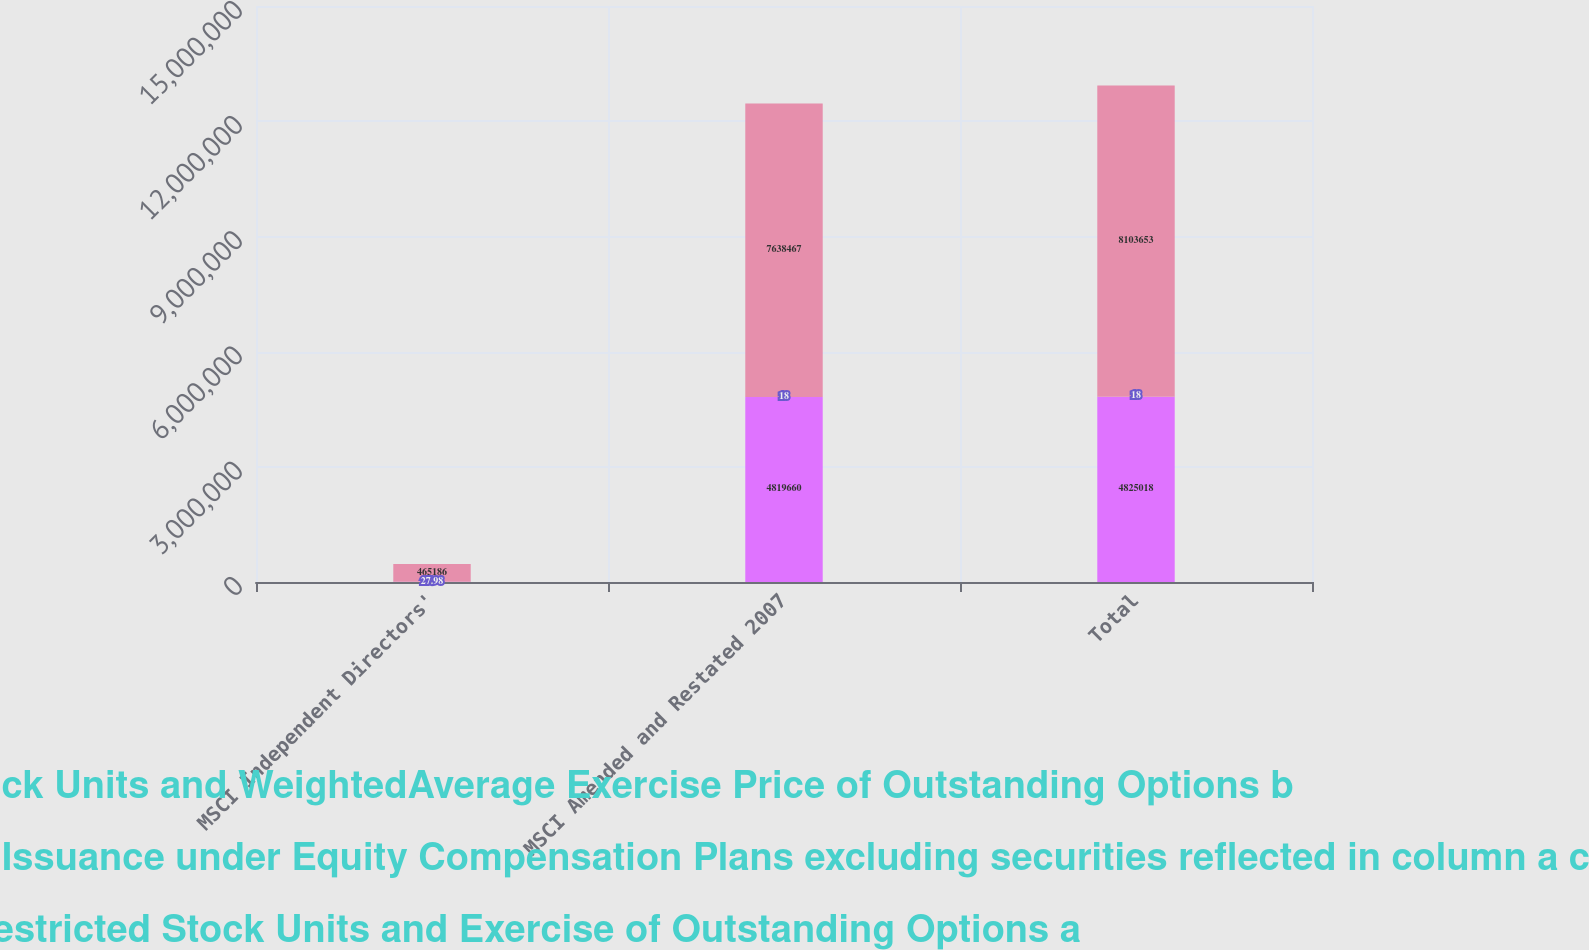Convert chart to OTSL. <chart><loc_0><loc_0><loc_500><loc_500><stacked_bar_chart><ecel><fcel>MSCI Independent Directors'<fcel>MSCI Amended and Restated 2007<fcel>Total<nl><fcel>Weighted Average Unit Award Value of Restricted Stock Units and WeightedAverage Exercise Price of Outstanding Options b<fcel>5358<fcel>4.81966e+06<fcel>4.82502e+06<nl><fcel>Number of Securities Remaining Available for Future Issuance under Equity Compensation Plans excluding securities reflected in column a c<fcel>27.98<fcel>18<fcel>18<nl><fcel>Number of Securities to be Issued Upon Vesting of Restricted Stock Units and Exercise of Outstanding Options a<fcel>465186<fcel>7.63847e+06<fcel>8.10365e+06<nl></chart> 